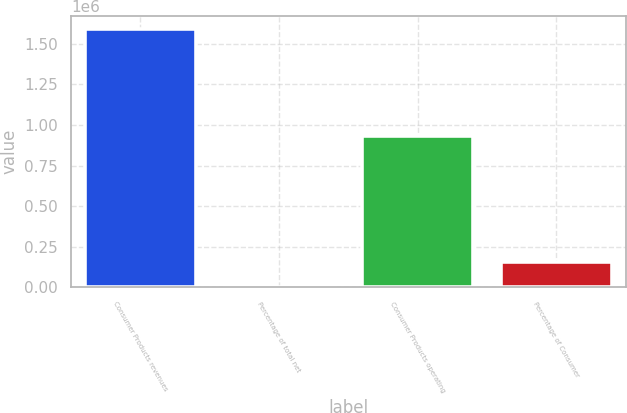Convert chart. <chart><loc_0><loc_0><loc_500><loc_500><bar_chart><fcel>Consumer Products revenues<fcel>Percentage of total net<fcel>Consumer Products operating<fcel>Percentage of Consumer<nl><fcel>1.5905e+06<fcel>30<fcel>931989<fcel>159078<nl></chart> 